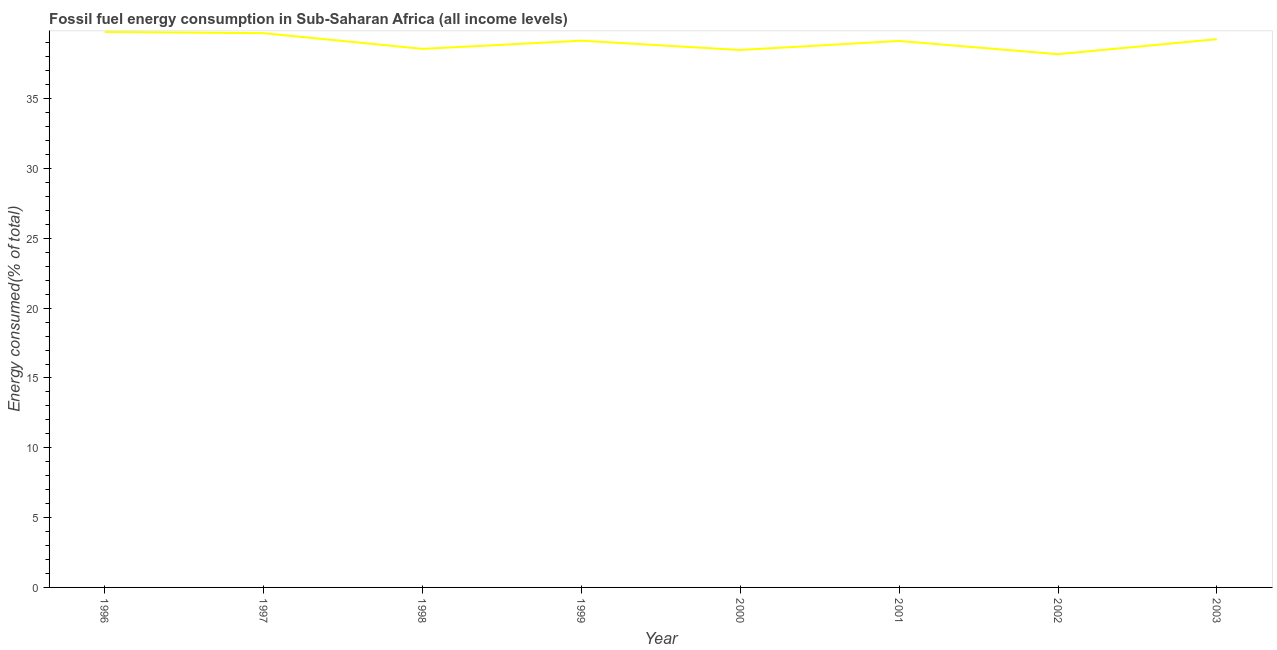What is the fossil fuel energy consumption in 1997?
Your answer should be very brief. 39.7. Across all years, what is the maximum fossil fuel energy consumption?
Keep it short and to the point. 39.78. Across all years, what is the minimum fossil fuel energy consumption?
Your answer should be compact. 38.19. In which year was the fossil fuel energy consumption maximum?
Ensure brevity in your answer.  1996. What is the sum of the fossil fuel energy consumption?
Ensure brevity in your answer.  312.29. What is the difference between the fossil fuel energy consumption in 1997 and 1999?
Offer a very short reply. 0.54. What is the average fossil fuel energy consumption per year?
Your answer should be compact. 39.04. What is the median fossil fuel energy consumption?
Your answer should be compact. 39.15. In how many years, is the fossil fuel energy consumption greater than 11 %?
Make the answer very short. 8. What is the ratio of the fossil fuel energy consumption in 2002 to that in 2003?
Provide a short and direct response. 0.97. Is the fossil fuel energy consumption in 1998 less than that in 2003?
Provide a succinct answer. Yes. Is the difference between the fossil fuel energy consumption in 1997 and 1999 greater than the difference between any two years?
Ensure brevity in your answer.  No. What is the difference between the highest and the second highest fossil fuel energy consumption?
Your response must be concise. 0.09. Is the sum of the fossil fuel energy consumption in 1996 and 2003 greater than the maximum fossil fuel energy consumption across all years?
Offer a very short reply. Yes. What is the difference between the highest and the lowest fossil fuel energy consumption?
Your response must be concise. 1.59. In how many years, is the fossil fuel energy consumption greater than the average fossil fuel energy consumption taken over all years?
Provide a succinct answer. 5. How many lines are there?
Ensure brevity in your answer.  1. How many years are there in the graph?
Your answer should be very brief. 8. What is the difference between two consecutive major ticks on the Y-axis?
Offer a terse response. 5. What is the title of the graph?
Your response must be concise. Fossil fuel energy consumption in Sub-Saharan Africa (all income levels). What is the label or title of the X-axis?
Your answer should be compact. Year. What is the label or title of the Y-axis?
Provide a short and direct response. Energy consumed(% of total). What is the Energy consumed(% of total) of 1996?
Provide a short and direct response. 39.78. What is the Energy consumed(% of total) of 1997?
Offer a terse response. 39.7. What is the Energy consumed(% of total) in 1998?
Offer a terse response. 38.57. What is the Energy consumed(% of total) of 1999?
Provide a short and direct response. 39.16. What is the Energy consumed(% of total) in 2000?
Offer a very short reply. 38.49. What is the Energy consumed(% of total) of 2001?
Provide a short and direct response. 39.14. What is the Energy consumed(% of total) in 2002?
Offer a terse response. 38.19. What is the Energy consumed(% of total) in 2003?
Keep it short and to the point. 39.27. What is the difference between the Energy consumed(% of total) in 1996 and 1997?
Offer a terse response. 0.09. What is the difference between the Energy consumed(% of total) in 1996 and 1998?
Your answer should be very brief. 1.21. What is the difference between the Energy consumed(% of total) in 1996 and 1999?
Ensure brevity in your answer.  0.63. What is the difference between the Energy consumed(% of total) in 1996 and 2000?
Your answer should be compact. 1.29. What is the difference between the Energy consumed(% of total) in 1996 and 2001?
Keep it short and to the point. 0.65. What is the difference between the Energy consumed(% of total) in 1996 and 2002?
Give a very brief answer. 1.59. What is the difference between the Energy consumed(% of total) in 1996 and 2003?
Keep it short and to the point. 0.52. What is the difference between the Energy consumed(% of total) in 1997 and 1998?
Keep it short and to the point. 1.12. What is the difference between the Energy consumed(% of total) in 1997 and 1999?
Provide a short and direct response. 0.54. What is the difference between the Energy consumed(% of total) in 1997 and 2000?
Provide a short and direct response. 1.2. What is the difference between the Energy consumed(% of total) in 1997 and 2001?
Ensure brevity in your answer.  0.56. What is the difference between the Energy consumed(% of total) in 1997 and 2002?
Your answer should be very brief. 1.5. What is the difference between the Energy consumed(% of total) in 1997 and 2003?
Your response must be concise. 0.43. What is the difference between the Energy consumed(% of total) in 1998 and 1999?
Give a very brief answer. -0.58. What is the difference between the Energy consumed(% of total) in 1998 and 2000?
Keep it short and to the point. 0.08. What is the difference between the Energy consumed(% of total) in 1998 and 2001?
Your response must be concise. -0.57. What is the difference between the Energy consumed(% of total) in 1998 and 2002?
Ensure brevity in your answer.  0.38. What is the difference between the Energy consumed(% of total) in 1998 and 2003?
Your response must be concise. -0.69. What is the difference between the Energy consumed(% of total) in 1999 and 2000?
Your answer should be compact. 0.67. What is the difference between the Energy consumed(% of total) in 1999 and 2001?
Offer a very short reply. 0.02. What is the difference between the Energy consumed(% of total) in 1999 and 2002?
Provide a succinct answer. 0.97. What is the difference between the Energy consumed(% of total) in 1999 and 2003?
Your answer should be compact. -0.11. What is the difference between the Energy consumed(% of total) in 2000 and 2001?
Offer a terse response. -0.65. What is the difference between the Energy consumed(% of total) in 2000 and 2002?
Make the answer very short. 0.3. What is the difference between the Energy consumed(% of total) in 2000 and 2003?
Offer a very short reply. -0.77. What is the difference between the Energy consumed(% of total) in 2001 and 2002?
Give a very brief answer. 0.95. What is the difference between the Energy consumed(% of total) in 2001 and 2003?
Your answer should be compact. -0.13. What is the difference between the Energy consumed(% of total) in 2002 and 2003?
Give a very brief answer. -1.08. What is the ratio of the Energy consumed(% of total) in 1996 to that in 1997?
Give a very brief answer. 1. What is the ratio of the Energy consumed(% of total) in 1996 to that in 1998?
Offer a very short reply. 1.03. What is the ratio of the Energy consumed(% of total) in 1996 to that in 2000?
Give a very brief answer. 1.03. What is the ratio of the Energy consumed(% of total) in 1996 to that in 2001?
Your answer should be compact. 1.02. What is the ratio of the Energy consumed(% of total) in 1996 to that in 2002?
Give a very brief answer. 1.04. What is the ratio of the Energy consumed(% of total) in 1996 to that in 2003?
Provide a succinct answer. 1.01. What is the ratio of the Energy consumed(% of total) in 1997 to that in 2000?
Offer a very short reply. 1.03. What is the ratio of the Energy consumed(% of total) in 1997 to that in 2001?
Your answer should be compact. 1.01. What is the ratio of the Energy consumed(% of total) in 1997 to that in 2002?
Make the answer very short. 1.04. What is the ratio of the Energy consumed(% of total) in 1997 to that in 2003?
Ensure brevity in your answer.  1.01. What is the ratio of the Energy consumed(% of total) in 1998 to that in 2000?
Give a very brief answer. 1. What is the ratio of the Energy consumed(% of total) in 1998 to that in 2001?
Offer a terse response. 0.99. What is the ratio of the Energy consumed(% of total) in 1998 to that in 2002?
Give a very brief answer. 1.01. What is the ratio of the Energy consumed(% of total) in 1998 to that in 2003?
Your response must be concise. 0.98. What is the ratio of the Energy consumed(% of total) in 1999 to that in 2001?
Provide a succinct answer. 1. What is the ratio of the Energy consumed(% of total) in 1999 to that in 2003?
Your response must be concise. 1. What is the ratio of the Energy consumed(% of total) in 2000 to that in 2003?
Make the answer very short. 0.98. What is the ratio of the Energy consumed(% of total) in 2001 to that in 2002?
Ensure brevity in your answer.  1.02. What is the ratio of the Energy consumed(% of total) in 2001 to that in 2003?
Make the answer very short. 1. What is the ratio of the Energy consumed(% of total) in 2002 to that in 2003?
Ensure brevity in your answer.  0.97. 